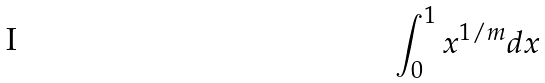<formula> <loc_0><loc_0><loc_500><loc_500>\int _ { 0 } ^ { 1 } x ^ { 1 / m } d x</formula> 